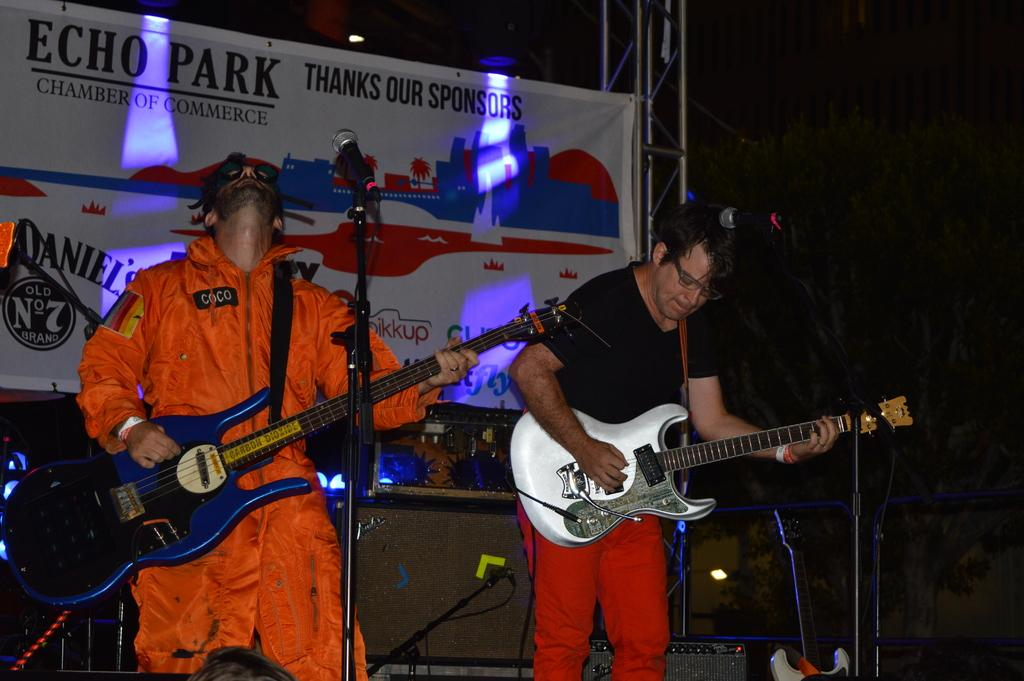How many people are in the image? There are two persons in the image. What are the persons doing in the image? The persons are playing musical instruments. What objects are in front of the persons? There are microphones in front of the persons. What can be seen in the background of the image? There is a banner in the background of the image. What is the aftermath of the musical performance in the image? There is no indication of a musical performance's aftermath in the image, as it only shows two persons playing musical instruments and microphones in front of them. 